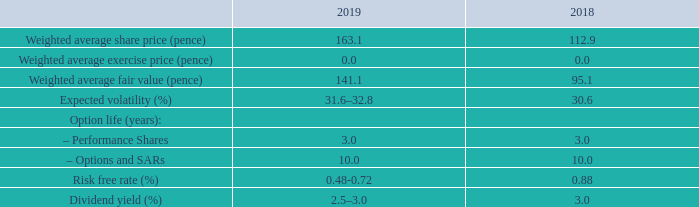34. Share-based payment continued
3.8 million share incentives were granted during 2019 (2018 2.7 million). The fair value of share incentives has been estimated as at the date of grant using the Black-Scholes binomial model. The following table gives the assumptions made in arriving at the share-based payment charge and the fair value:
The expected volatility was determined by calculating the historical volatility of the Company’s share price over the previous two years which management considers to be the period which is likely to be most representative of future volatility. The risk free rate is calculated by reference to UK government bonds.
How is the fair value of share incentives estimated? At the date of grant using the black-scholes binomial model. How was the expected volatility determined? By calculating the historical volatility of the company’s share price over the previous two years which management considers to be the period which is likely to be most representative of future volatility. What are the different option life (years) provided in the table with the assumptions in arriving at the share-based payment charge and the fair value? Performance shares, options and sars. In which year was the Weighted average fair value (pence) larger? 141.1>95.1
Answer: 2019. What was the change in the Weighted average share price (pence)? 163.1-112.9
Answer: 50.2. What was the percentage change in the Weighted average share price (pence)?
Answer scale should be: percent. (163.1-112.9)/112.9
Answer: 44.46. 